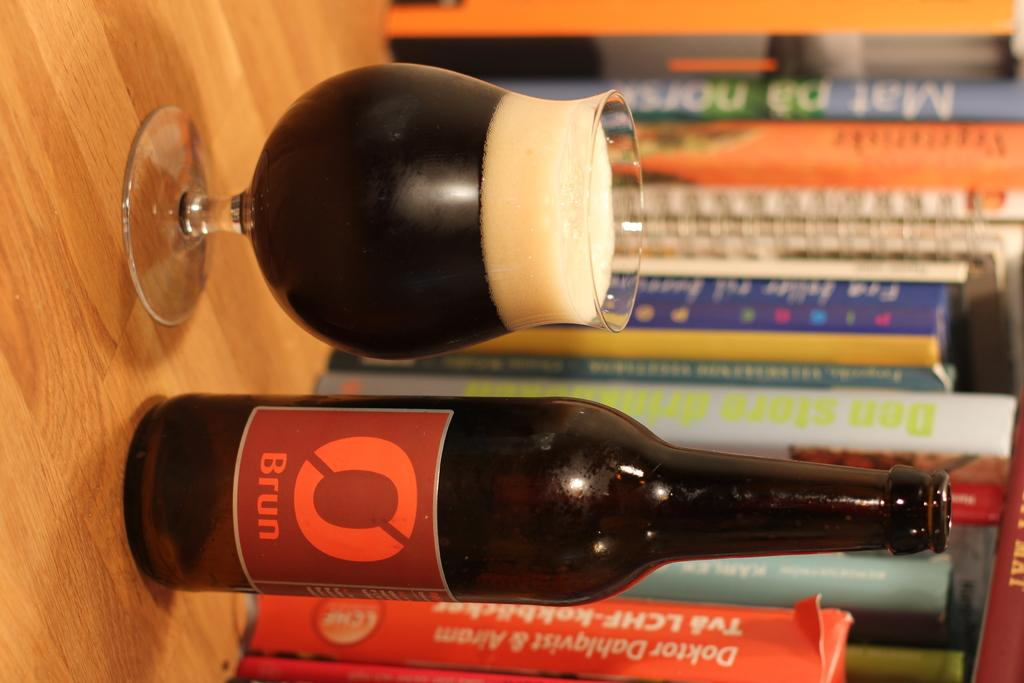<image>
Provide a brief description of the given image. A bottle of Brun beer is poured into a glass by some books. 